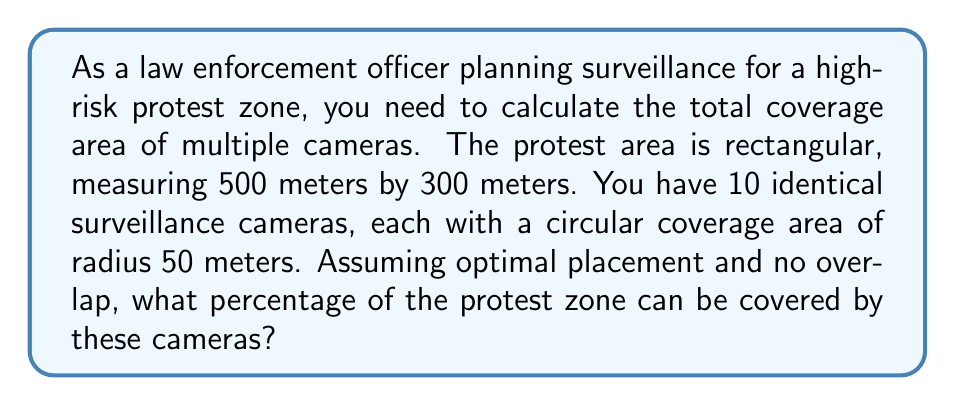Help me with this question. To solve this problem, we need to follow these steps:

1. Calculate the total area of the protest zone:
   $$ A_{zone} = 500\text{ m} \times 300\text{ m} = 150,000\text{ m}^2 $$

2. Calculate the coverage area of a single camera:
   $$ A_{camera} = \pi r^2 = \pi (50\text{ m})^2 = 7,853.98\text{ m}^2 $$

3. Calculate the total coverage area of all 10 cameras:
   $$ A_{total} = 10 \times 7,853.98\text{ m}^2 = 78,539.8\text{ m}^2 $$

4. Calculate the percentage of the protest zone covered:
   $$ \text{Percentage covered} = \frac{A_{total}}{A_{zone}} \times 100\% $$
   $$ = \frac{78,539.8\text{ m}^2}{150,000\text{ m}^2} \times 100\% = 52.36\% $$

Therefore, assuming optimal placement and no overlap, the 10 cameras can cover 52.36% of the protest zone.
Answer: 52.36% 